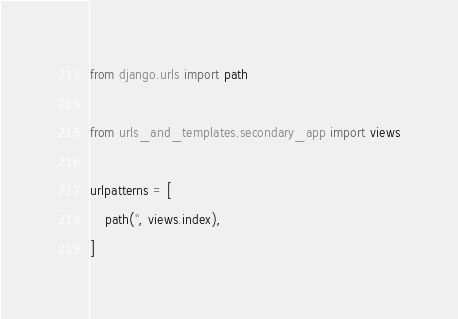<code> <loc_0><loc_0><loc_500><loc_500><_Python_>from django.urls import path

from urls_and_templates.secondary_app import views

urlpatterns = [
    path('', views.index),
]</code> 